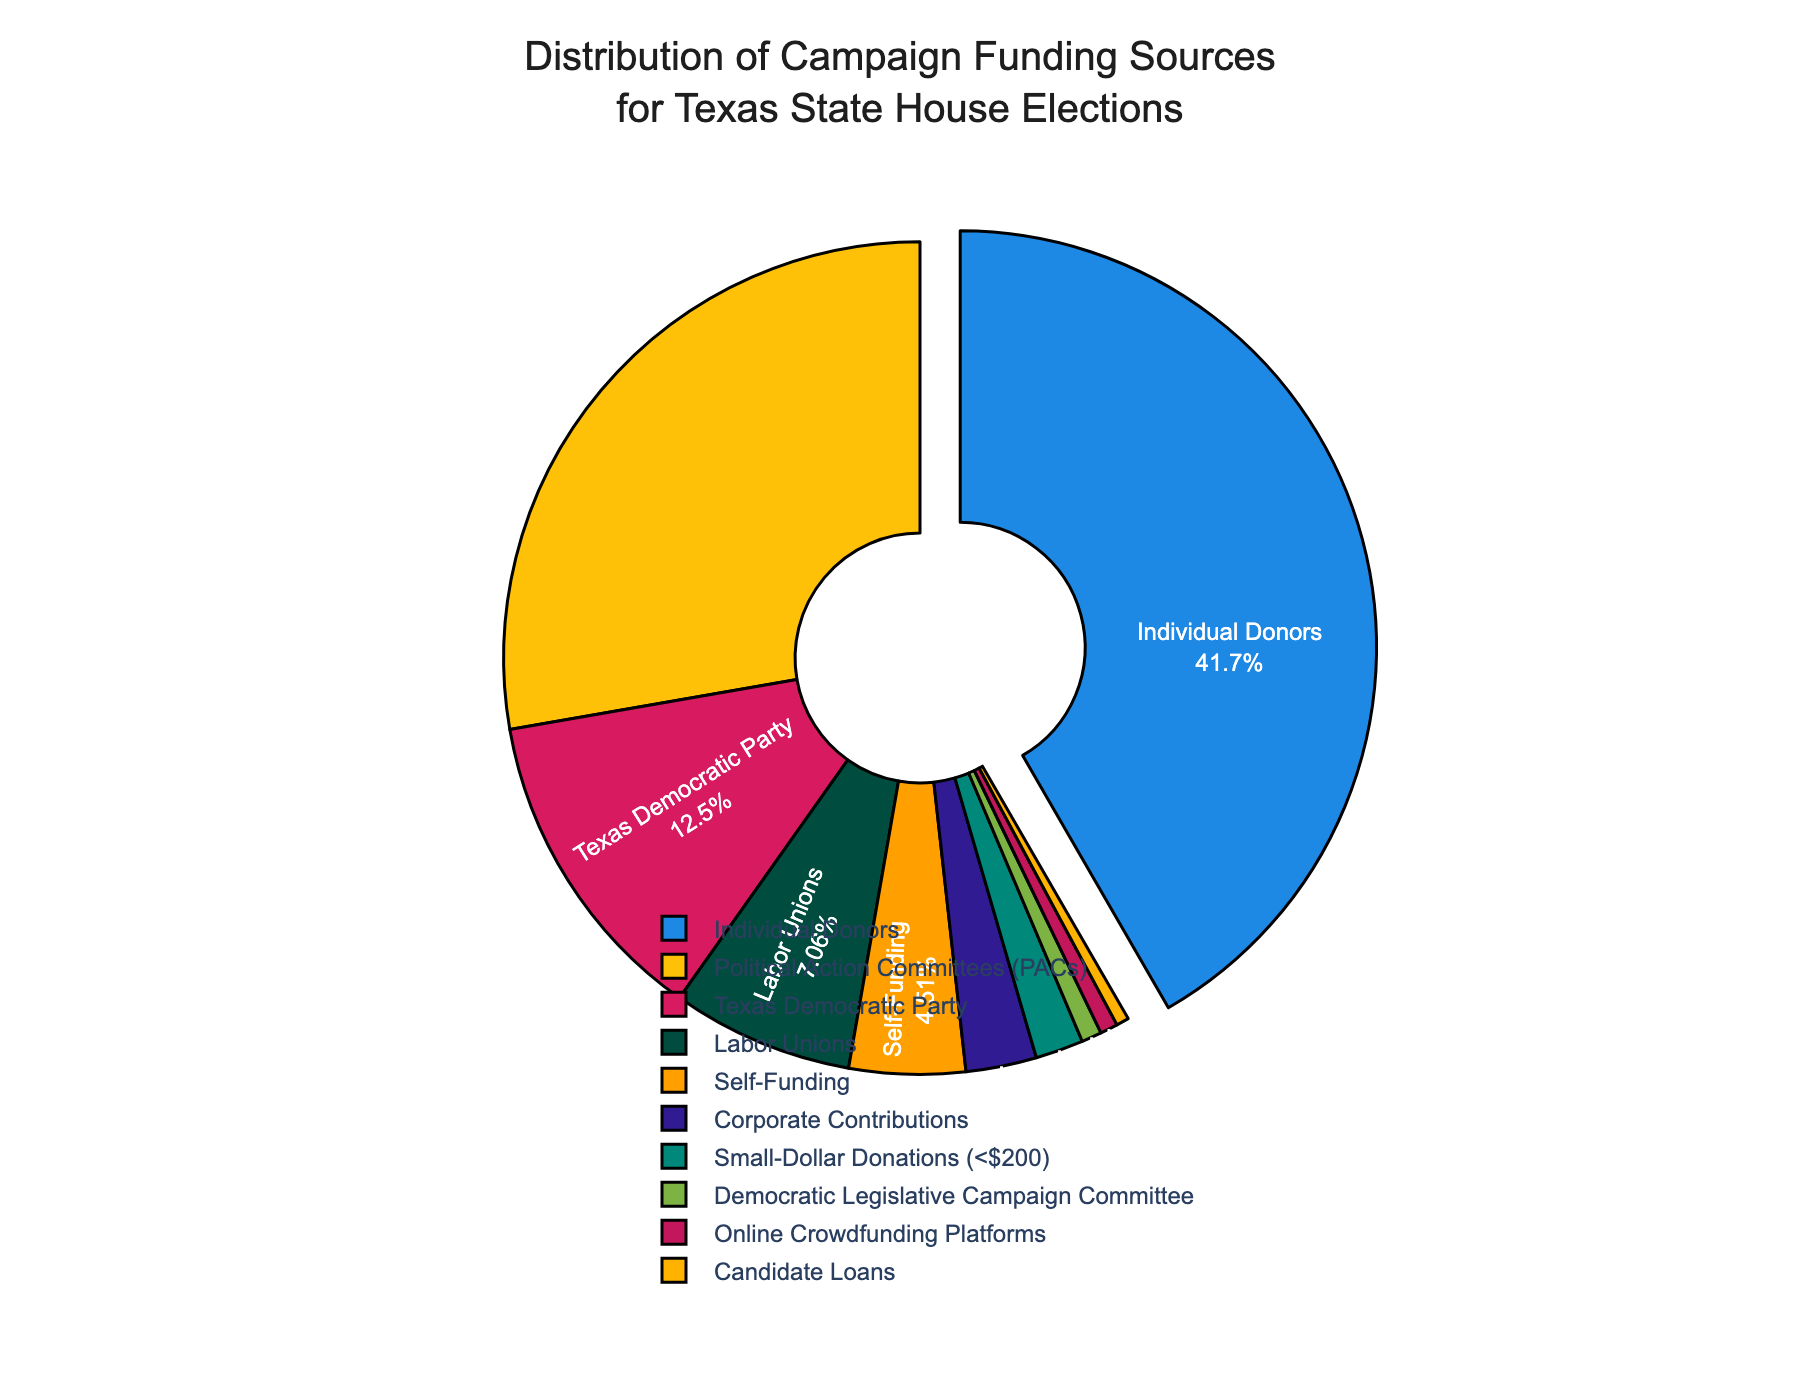What's the largest source of campaign funding? The pie chart shows the proportions of different funding categories. The largest slice is for "Individual Donors" with 42.5%.
Answer: Individual Donors What's the combined percentage of funding from Political Action Committees (PACs) and the Texas Democratic Party? Adding the percentages from PACs and the Texas Democratic Party: 28.3% + 12.7% = 41.0%.
Answer: 41.0% Which funding source contributes the least to campaign funding? The smallest slice on the pie chart represents "Candidate Loans" at 0.5%.
Answer: Candidate Loans How much more do Individual Donors contribute compared to Corporate Contributions? Subtract the percentage of Corporate Contributions from Individual Donors: 42.5% - 2.8% = 39.7%.
Answer: 39.7% What is the sum of the contributions from all sources other than Individual Donors? Sum all percentages except for Individual Donors: 28.3 + 12.7 + 7.2 + 4.6 + 2.8 + 1.9 + 0.8 + 0.7 + 0.5 = 59.1%.
Answer: 59.1% Identify the color representing the Labor Unions funding source. The color representing Labor Unions on the pie chart is a dark shade as it is the fifth largest category with 7.2%.
Answer: Dark green Which funding sources provide less than 5% of the total contributions individually? The categories with less than 5% contributions are Self-Funding (4.6%), Corporate Contributions (2.8%), Small-Dollar Donations (1.9%), Democratic Legislative Campaign Committee (0.8%), Online Crowdfunding Platforms (0.7%), and Candidate Loans (0.5%).
Answer: Self-Funding, Corporate Contributions, Small-Dollar Donations, Democratic Legislative Campaign Committee, Online Crowdfunding Platforms, Candidate Loans What is the average percentage of contributions from the four smallest funding sources? Sum the percentages of the four smallest sources and divide by 4: (0.8 + 0.7 + 0.5 + 1.9) / 4 = 3.9 / 4 = 0.975%.
Answer: 0.975% How do contributions from the Texas Democratic Party compare to Labor Unions? The pie chart shows the Texas Democratic Party contributes 12.7% and Labor Unions contribute 7.2%. Since 12.7% > 7.2%, the Texas Democratic Party contributes more.
Answer: Texas Democratic Party contributes more What's the total percentage of contributions that come from online sources? The online sources are Online Crowdfunding Platforms and Small-Dollar Donations. Their combined percentage is 0.7% + 1.9% = 2.6%.
Answer: 2.6% 